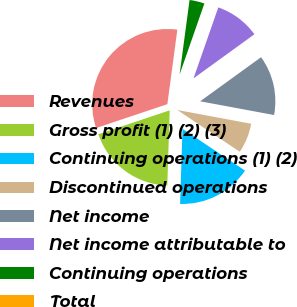<chart> <loc_0><loc_0><loc_500><loc_500><pie_chart><fcel>Revenues<fcel>Gross profit (1) (2) (3)<fcel>Continuing operations (1) (2)<fcel>Discontinued operations<fcel>Net income<fcel>Net income attributable to<fcel>Continuing operations<fcel>Total<nl><fcel>32.26%<fcel>19.35%<fcel>16.13%<fcel>6.45%<fcel>12.9%<fcel>9.68%<fcel>3.23%<fcel>0.0%<nl></chart> 